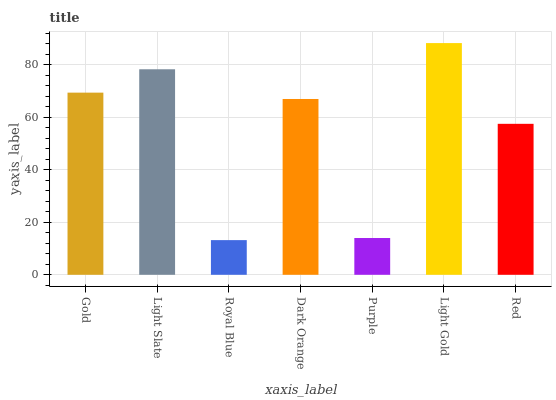Is Light Slate the minimum?
Answer yes or no. No. Is Light Slate the maximum?
Answer yes or no. No. Is Light Slate greater than Gold?
Answer yes or no. Yes. Is Gold less than Light Slate?
Answer yes or no. Yes. Is Gold greater than Light Slate?
Answer yes or no. No. Is Light Slate less than Gold?
Answer yes or no. No. Is Dark Orange the high median?
Answer yes or no. Yes. Is Dark Orange the low median?
Answer yes or no. Yes. Is Red the high median?
Answer yes or no. No. Is Royal Blue the low median?
Answer yes or no. No. 